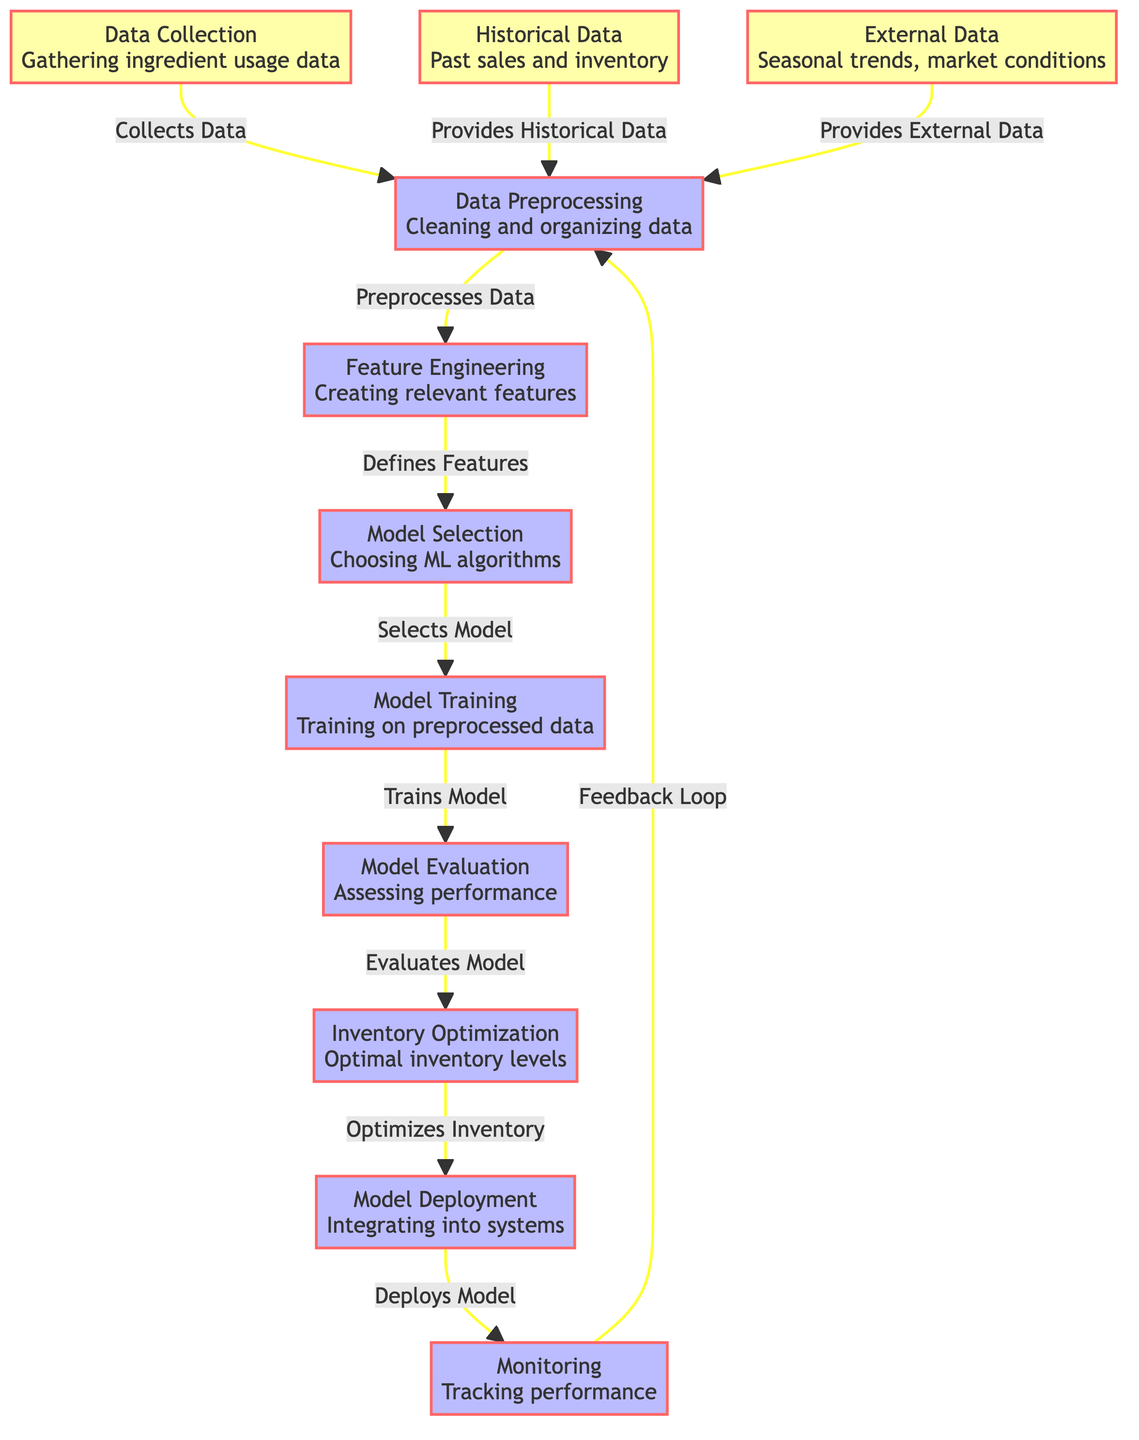What is the first step in the inventory optimization process? The first step is "Data Collection," which involves gathering ingredient usage data.
Answer: Data Collection How many main processes are involved in the diagram? There are six main processes shown, which include Data Preprocessing, Feature Engineering, Model Selection, Model Training, Model Evaluation, Inventory Optimization, and Model Deployment.
Answer: Six What types of data are being collected in the diagram? Three types of data are mentioned: ingredient usage data, historical data, and external data.
Answer: Ingredient usage data, historical data, external data What is the relationship between Model Training and Model Evaluation? Model Training occurs after Model Selection and feeds into Model Evaluation, indicating that the model is trained before its performance is assessed.
Answer: Model Training leads to Model Evaluation Which step comes directly after Model Deployment? The step that comes directly after Model Deployment is Monitoring, where the system performance is tracked.
Answer: Monitoring How does the diagram represent the feedback loop? The feedback loop is represented by the arrow from Monitoring back to Data Preprocessing, indicating that performance tracking informs subsequent data preprocessing.
Answer: Arrow from Monitoring to Data Preprocessing What is the purpose of Feature Engineering in the diagram? The purpose of Feature Engineering is to create relevant features from the preprocessed data that will be used for model selection.
Answer: Creating relevant features How does external data influence the inventory optimization process? External data provides insights into seasonal trends and market conditions, which are essential for accurate inventory optimization.
Answer: Provides insights into seasonal trends and market conditions Which process follows Model Evaluation? The process that follows Model Evaluation is Inventory Optimization, where optimal inventory levels are determined.
Answer: Inventory Optimization 